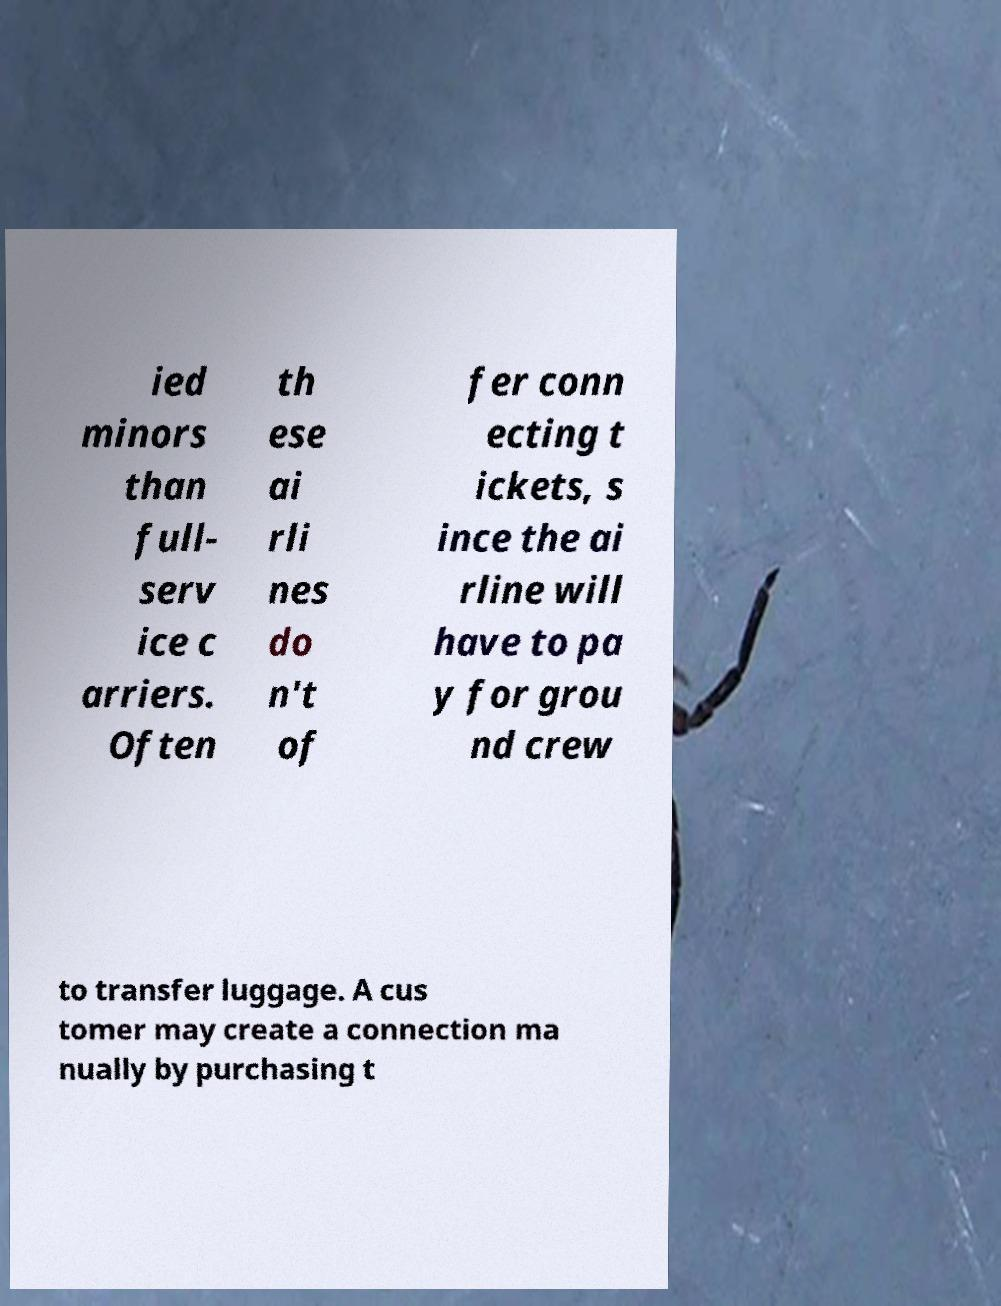For documentation purposes, I need the text within this image transcribed. Could you provide that? ied minors than full- serv ice c arriers. Often th ese ai rli nes do n't of fer conn ecting t ickets, s ince the ai rline will have to pa y for grou nd crew to transfer luggage. A cus tomer may create a connection ma nually by purchasing t 